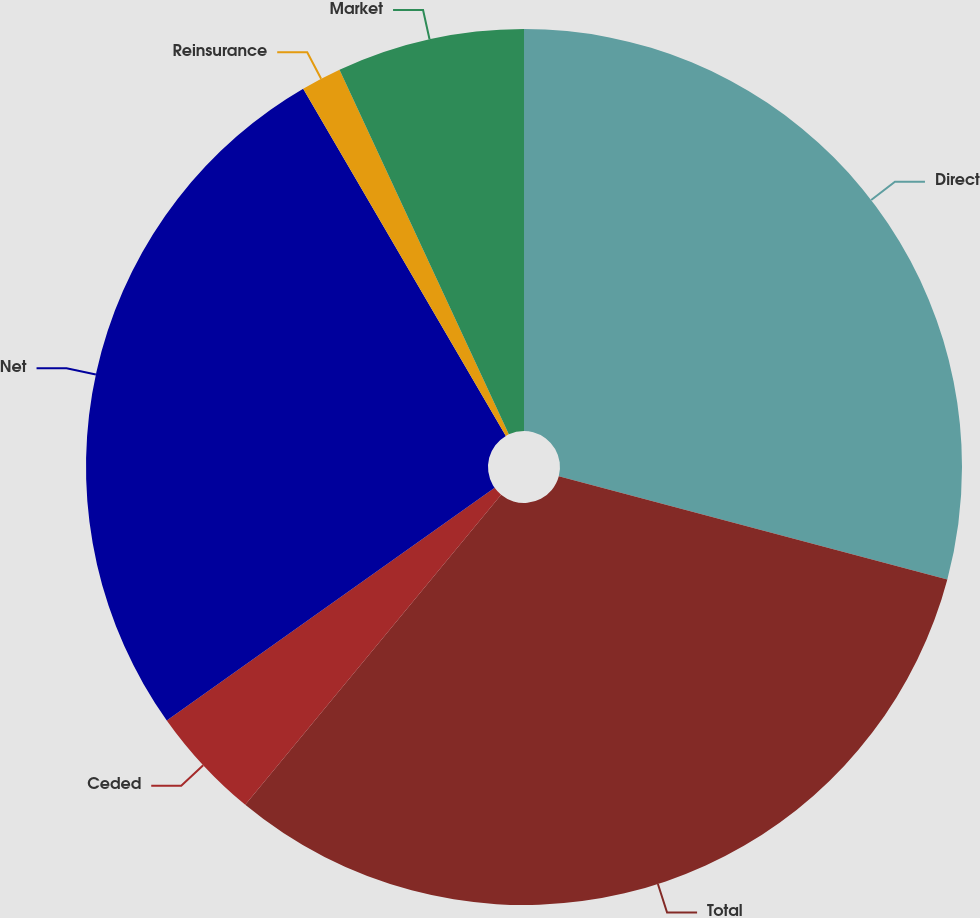Convert chart to OTSL. <chart><loc_0><loc_0><loc_500><loc_500><pie_chart><fcel>Direct<fcel>Total<fcel>Ceded<fcel>Net<fcel>Reinsurance<fcel>Market<nl><fcel>29.13%<fcel>31.85%<fcel>4.2%<fcel>26.41%<fcel>1.49%<fcel>6.92%<nl></chart> 